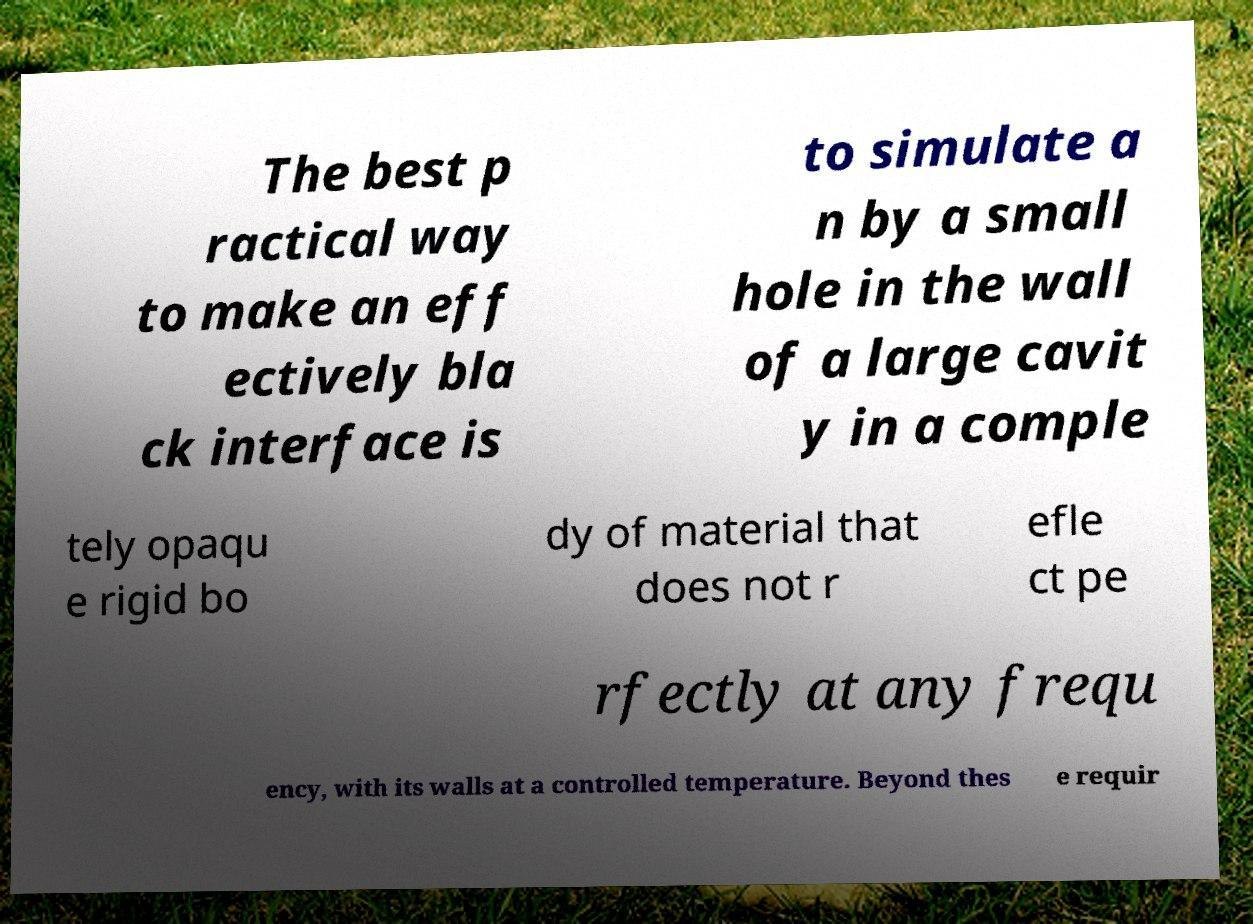Please read and relay the text visible in this image. What does it say? The best p ractical way to make an eff ectively bla ck interface is to simulate a n by a small hole in the wall of a large cavit y in a comple tely opaqu e rigid bo dy of material that does not r efle ct pe rfectly at any frequ ency, with its walls at a controlled temperature. Beyond thes e requir 